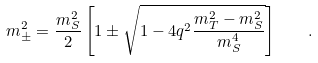Convert formula to latex. <formula><loc_0><loc_0><loc_500><loc_500>m ^ { 2 } _ { \pm } = \frac { m _ { S } ^ { 2 } } { 2 } \left [ 1 \pm \sqrt { 1 - 4 q ^ { 2 } \frac { m _ { T } ^ { 2 } - m _ { S } ^ { 2 } } { m _ { S } ^ { 4 } } } \right ] \quad .</formula> 